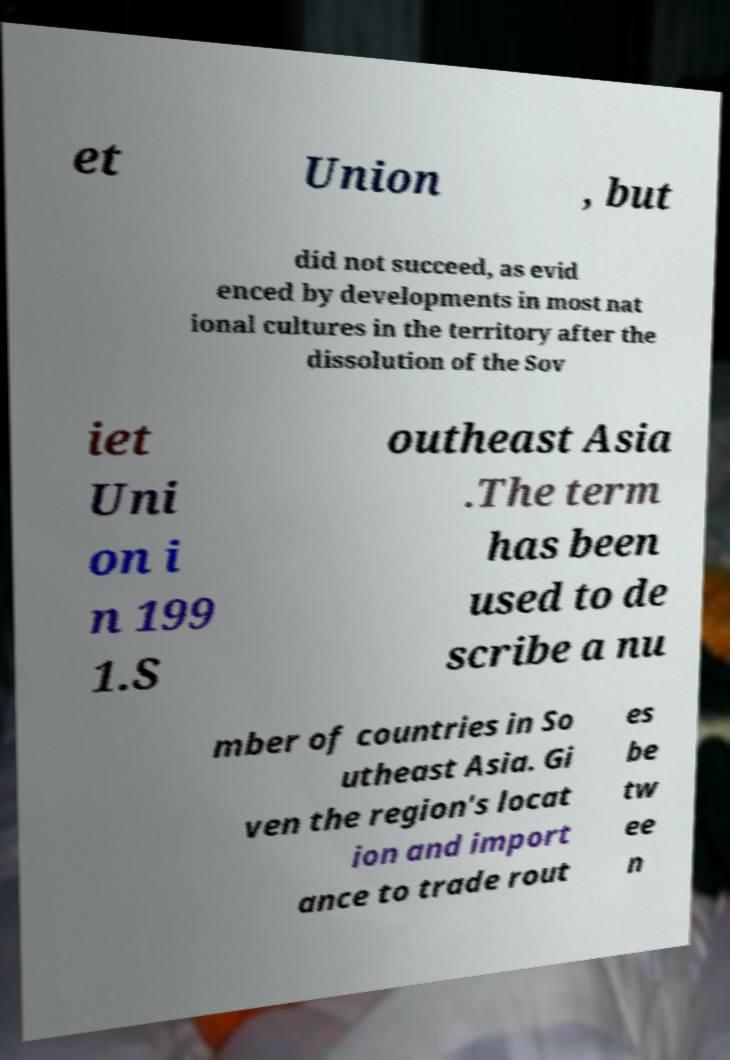Can you accurately transcribe the text from the provided image for me? et Union , but did not succeed, as evid enced by developments in most nat ional cultures in the territory after the dissolution of the Sov iet Uni on i n 199 1.S outheast Asia .The term has been used to de scribe a nu mber of countries in So utheast Asia. Gi ven the region's locat ion and import ance to trade rout es be tw ee n 